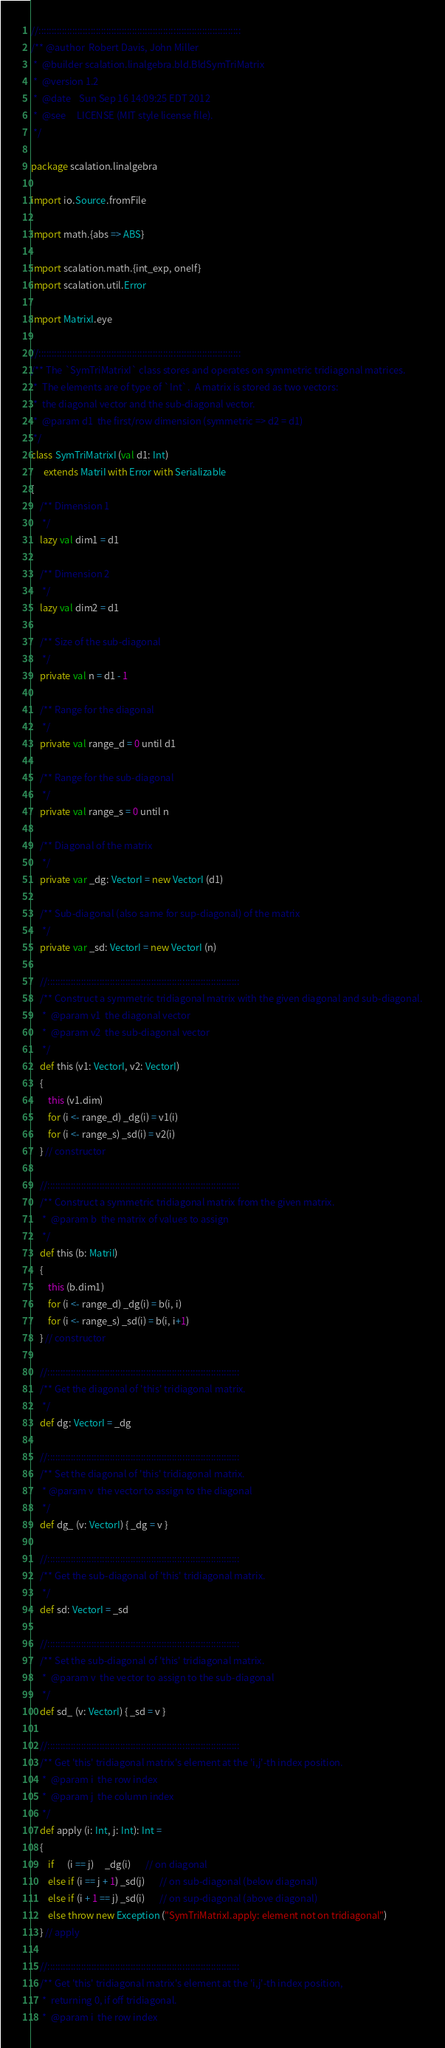<code> <loc_0><loc_0><loc_500><loc_500><_Scala_>
//::::::::::::::::::::::::::::::::::::::::::::::::::::::::::::::::::::::::::::::
/** @author  Robert Davis, John Miller
 *  @builder scalation.linalgebra.bld.BldSymTriMatrix
 *  @version 1.2
 *  @date    Sun Sep 16 14:09:25 EDT 2012
 *  @see     LICENSE (MIT style license file).
 */

package scalation.linalgebra

import io.Source.fromFile

import math.{abs => ABS}

import scalation.math.{int_exp, oneIf}
import scalation.util.Error

import MatrixI.eye

//::::::::::::::::::::::::::::::::::::::::::::::::::::::::::::::::::::::::::::::
/** The `SymTriMatrixI` class stores and operates on symmetric tridiagonal matrices.
 *  The elements are of type of `Int`.  A matrix is stored as two vectors:
 *  the diagonal vector and the sub-diagonal vector.
 *  @param d1  the first/row dimension (symmetric => d2 = d1)
 */
class SymTriMatrixI (val d1: Int)
      extends MatriI with Error with Serializable
{
    /** Dimension 1
     */
    lazy val dim1 = d1

    /** Dimension 2
     */
    lazy val dim2 = d1

    /** Size of the sub-diagonal
     */
    private val n = d1 - 1

    /** Range for the diagonal
     */
    private val range_d = 0 until d1

    /** Range for the sub-diagonal
     */
    private val range_s = 0 until n

    /** Diagonal of the matrix
     */
    private var _dg: VectorI = new VectorI (d1)

    /** Sub-diagonal (also same for sup-diagonal) of the matrix
     */
    private var _sd: VectorI = new VectorI (n)

    //::::::::::::::::::::::::::::::::::::::::::::::::::::::::::::::::::::::::::
    /** Construct a symmetric tridiagonal matrix with the given diagonal and sub-diagonal.
     *  @param v1  the diagonal vector
     *  @param v2  the sub-diagonal vector
     */
    def this (v1: VectorI, v2: VectorI)
    {
        this (v1.dim)
        for (i <- range_d) _dg(i) = v1(i)
        for (i <- range_s) _sd(i) = v2(i)
    } // constructor

    //::::::::::::::::::::::::::::::::::::::::::::::::::::::::::::::::::::::::::
    /** Construct a symmetric tridiagonal matrix from the given matrix.
     *  @param b  the matrix of values to assign
     */
    def this (b: MatriI)
    {
        this (b.dim1)
        for (i <- range_d) _dg(i) = b(i, i)
        for (i <- range_s) _sd(i) = b(i, i+1)
    } // constructor

    //::::::::::::::::::::::::::::::::::::::::::::::::::::::::::::::::::::::::::
    /** Get the diagonal of 'this' tridiagonal matrix.
     */
    def dg: VectorI = _dg

    //::::::::::::::::::::::::::::::::::::::::::::::::::::::::::::::::::::::::::
    /** Set the diagonal of 'this' tridiagonal matrix.
     * @param v  the vector to assign to the diagonal
     */
    def dg_ (v: VectorI) { _dg = v }

    //::::::::::::::::::::::::::::::::::::::::::::::::::::::::::::::::::::::::::
    /** Get the sub-diagonal of 'this' tridiagonal matrix.
     */
    def sd: VectorI = _sd

    //::::::::::::::::::::::::::::::::::::::::::::::::::::::::::::::::::::::::::
    /** Set the sub-diagonal of 'this' tridiagonal matrix.
     *  @param v  the vector to assign to the sub-diagonal
     */
    def sd_ (v: VectorI) { _sd = v }

    //::::::::::::::::::::::::::::::::::::::::::::::::::::::::::::::::::::::::::
    /** Get 'this' tridiagonal matrix's element at the 'i,j'-th index position.
     *  @param i  the row index
     *  @param j  the column index
     */
    def apply (i: Int, j: Int): Int = 
    {
        if      (i == j)     _dg(i)       // on diagonal
        else if (i == j + 1) _sd(j)       // on sub-diagonal (below diagonal)
        else if (i + 1 == j) _sd(i)       // on sup-diagonal (above diagonal)
        else throw new Exception ("SymTriMatrixI.apply: element not on tridiagonal")
    } // apply

    //::::::::::::::::::::::::::::::::::::::::::::::::::::::::::::::::::::::::::
    /** Get 'this' tridiagonal matrix's element at the 'i,j'-th index position,
     *  returning 0, if off tridiagonal.
     *  @param i  the row index</code> 